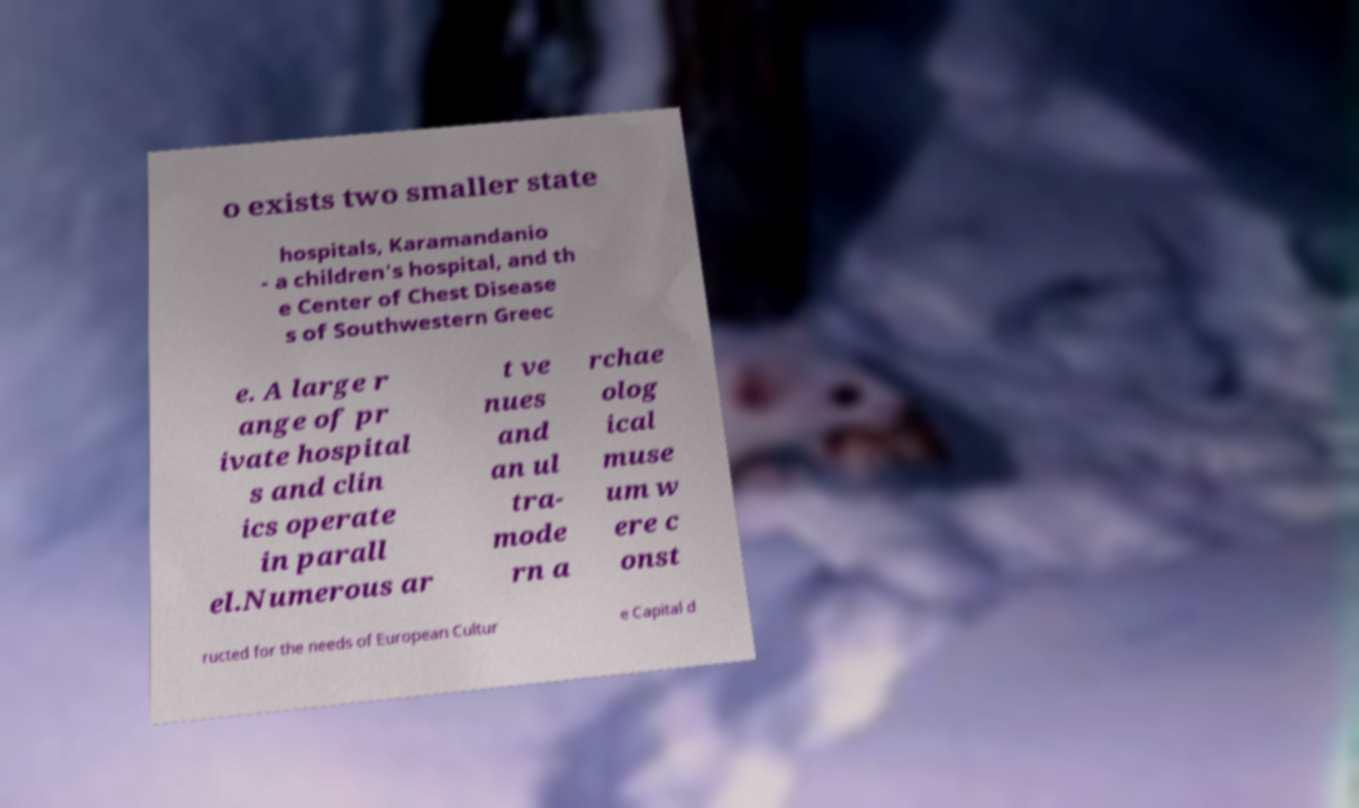Can you read and provide the text displayed in the image?This photo seems to have some interesting text. Can you extract and type it out for me? o exists two smaller state hospitals, Karamandanio - a children's hospital, and th e Center of Chest Disease s of Southwestern Greec e. A large r ange of pr ivate hospital s and clin ics operate in parall el.Numerous ar t ve nues and an ul tra- mode rn a rchae olog ical muse um w ere c onst ructed for the needs of European Cultur e Capital d 